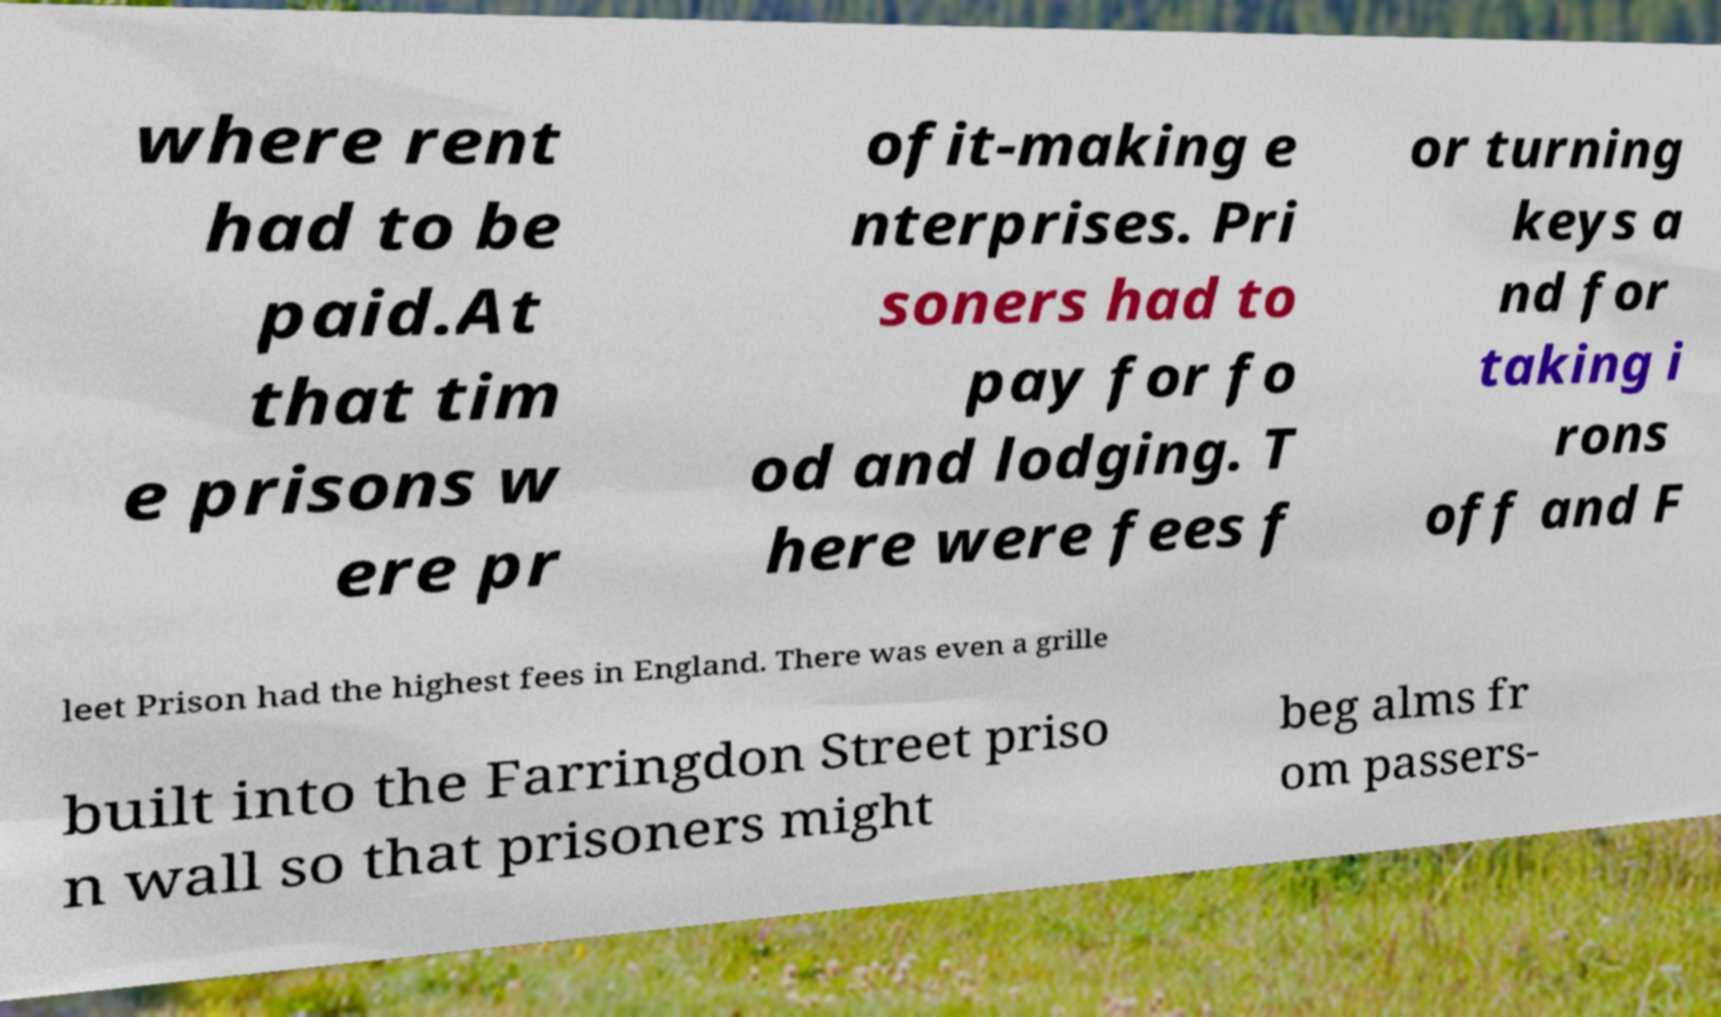There's text embedded in this image that I need extracted. Can you transcribe it verbatim? where rent had to be paid.At that tim e prisons w ere pr ofit-making e nterprises. Pri soners had to pay for fo od and lodging. T here were fees f or turning keys a nd for taking i rons off and F leet Prison had the highest fees in England. There was even a grille built into the Farringdon Street priso n wall so that prisoners might beg alms fr om passers- 